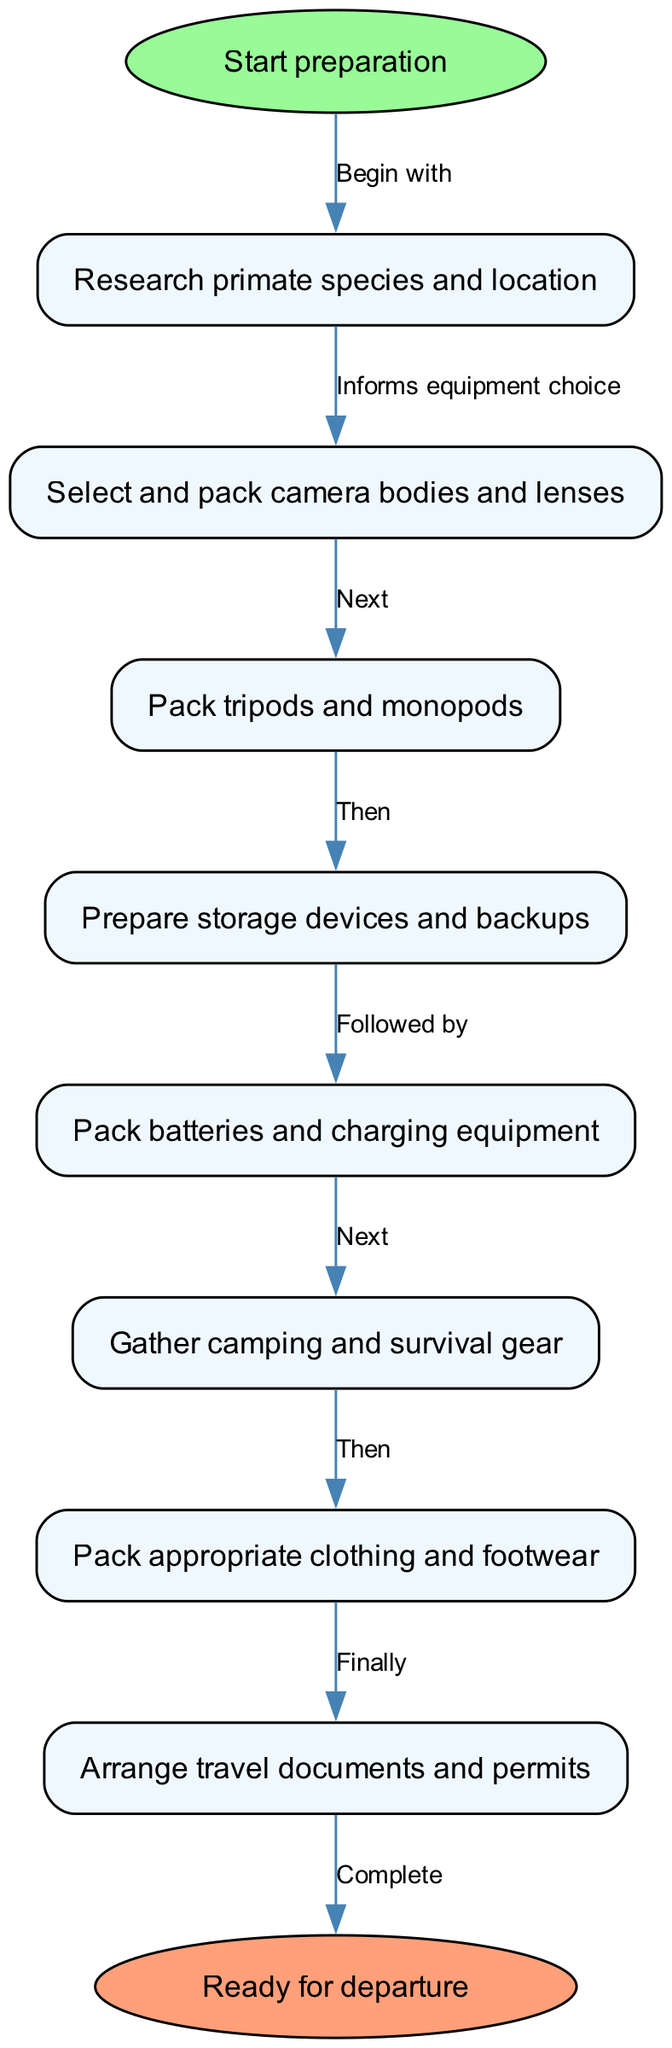What is the first step in the preparation process? The diagram indicates that the first step is labeled as "Start preparation," which leads to the next action of "Research primate species and location."
Answer: Start preparation How many total nodes are in the diagram? By counting all the distinct nodes listed in the diagram, we find there are a total of 10 nodes, including both the start and end nodes.
Answer: 10 What node comes after "Pack batteries and charging equipment"? Following the flow from "Pack batteries and charging equipment," the next node is "Gather camping and survival gear."
Answer: Gather camping and survival gear What is the last step before completing the preparation? The final task before reaching the "Ready for departure" node is "Arrange travel documents and permits."
Answer: Arrange travel documents and permits Which node directly informs equipment choice? The node that directly informs equipment choice is "Research primate species and location," as indicated by the edge that leads from it to "Select and pack camera bodies and lenses."
Answer: Research primate species and location If the researcher starts with successful "Research primate species and location," what node follows next in the flow? If the researcher successfully completes the "Research primate species and location" step, the next action in the flow would be to "Select and pack camera bodies and lenses."
Answer: Select and pack camera bodies and lenses What color is used for the "Ready for departure" node? The "Ready for departure" node is highlighted with a fill color of "#FFA07A," indicating it is the end point of the workflow.
Answer: #FFA07A In which stage is camping gear gathered? The stage at which camping gear is gathered is clearly indicated as "Gather camping and survival gear," which comes after packing batteries and charging equipment.
Answer: Gather camping and survival gear 